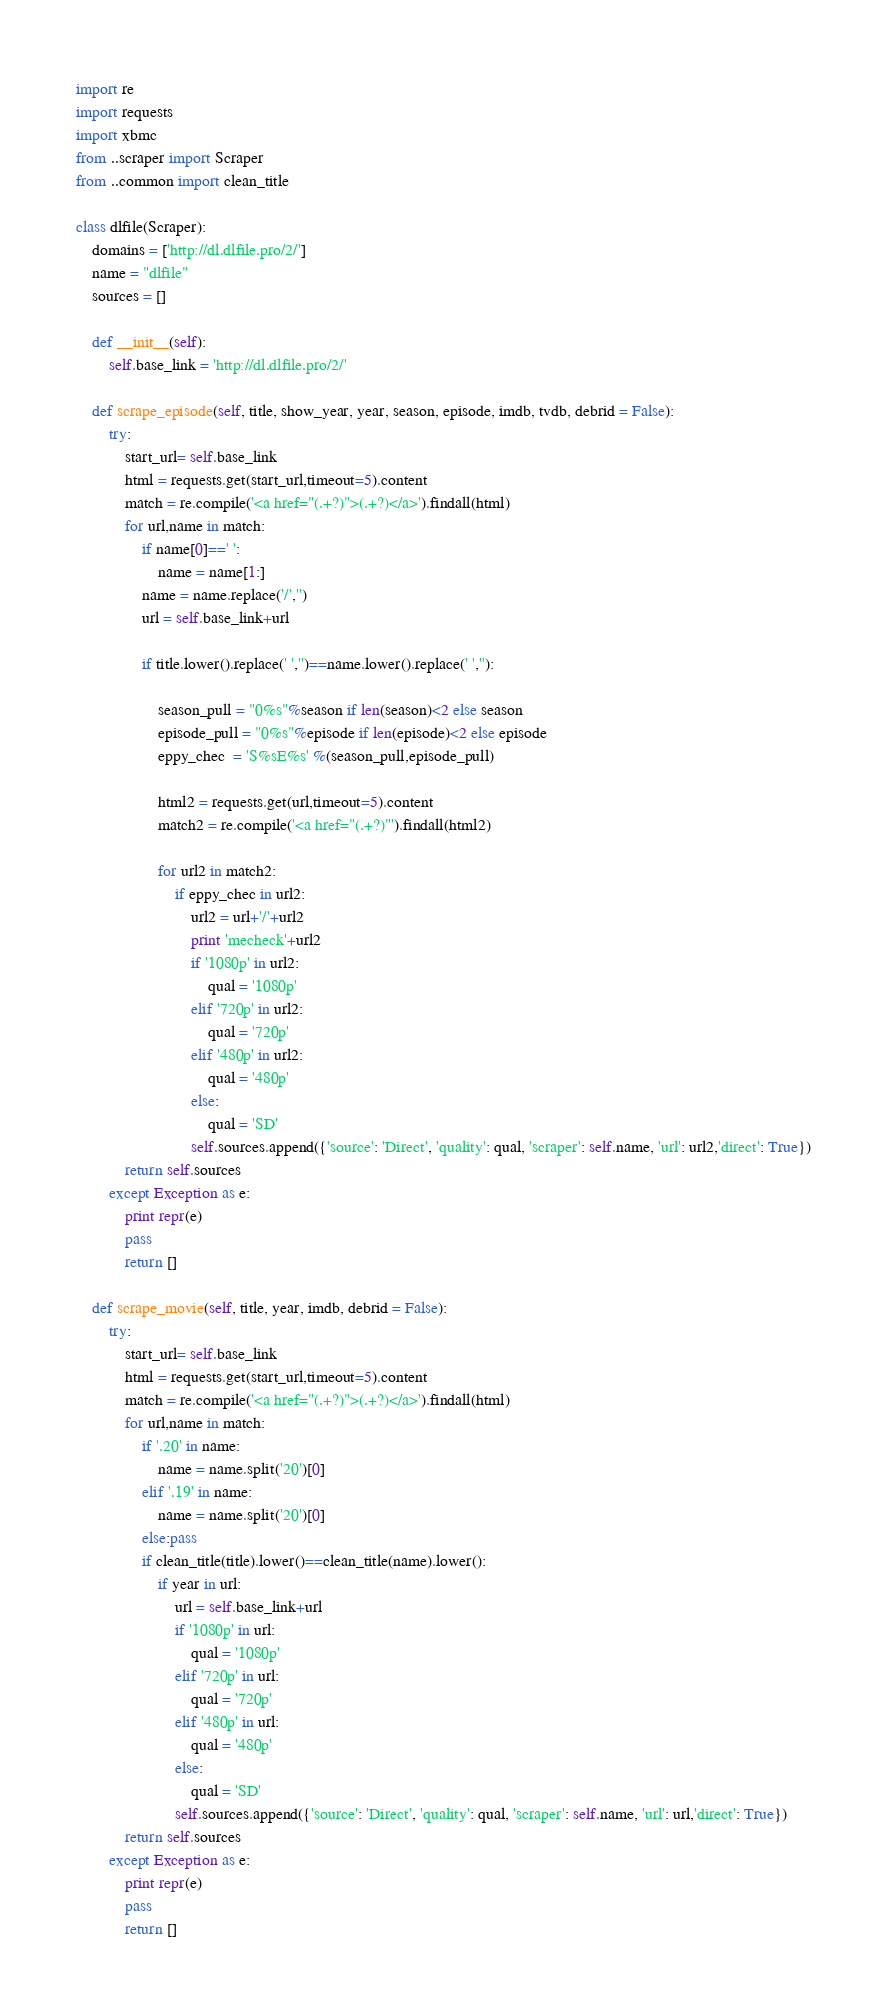<code> <loc_0><loc_0><loc_500><loc_500><_Python_>import re
import requests
import xbmc
from ..scraper import Scraper
from ..common import clean_title

class dlfile(Scraper):
    domains = ['http://dl.dlfile.pro/2/']
    name = "dlfile"
    sources = []

    def __init__(self):
        self.base_link = 'http://dl.dlfile.pro/2/'
                          
    def scrape_episode(self, title, show_year, year, season, episode, imdb, tvdb, debrid = False):
        try:
            start_url= self.base_link
            html = requests.get(start_url,timeout=5).content                               
            match = re.compile('<a href="(.+?)">(.+?)</a>').findall(html)                  
            for url,name in match:
                if name[0]==' ':
                    name = name[1:]
                name = name.replace('/','')
                url = self.base_link+url                                                 

                if title.lower().replace(' ','')==name.lower().replace(' ',''):          
                    
                    season_pull = "0%s"%season if len(season)<2 else season              
                    episode_pull = "0%s"%episode if len(episode)<2 else episode          
                    eppy_chec  = 'S%sE%s' %(season_pull,episode_pull)                    
                    
                    html2 = requests.get(url,timeout=5).content                          
                    match2 = re.compile('<a href="(.+?)"').findall(html2)                

                    for url2 in match2:
                        if eppy_chec in url2:                                            
                            url2 = url+'/'+url2                                          
                            print 'mecheck'+url2
                            if '1080p' in url2:                                         
                                qual = '1080p'
                            elif '720p' in url2: 
                                qual = '720p'
                            elif '480p' in url2:
                                qual = '480p'
                            else:
                                qual = 'SD'
                            self.sources.append({'source': 'Direct', 'quality': qual, 'scraper': self.name, 'url': url2,'direct': True})
            return self.sources
        except Exception as e:
            print repr(e)
            pass
            return []

    def scrape_movie(self, title, year, imdb, debrid = False):
        try:
            start_url= self.base_link
            html = requests.get(start_url,timeout=5).content 
            match = re.compile('<a href="(.+?)">(.+?)</a>').findall(html)
            for url,name in match:
                if '.20' in name:
                    name = name.split('20')[0]
                elif '.19' in name:
                    name = name.split('20')[0]
                else:pass
                if clean_title(title).lower()==clean_title(name).lower():
                    if year in url:
                        url = self.base_link+url
                        if '1080p' in url:                                          
                            qual = '1080p'
                        elif '720p' in url: 
                            qual = '720p'
                        elif '480p' in url:
                            qual = '480p'
                        else:
                            qual = 'SD'
                        self.sources.append({'source': 'Direct', 'quality': qual, 'scraper': self.name, 'url': url,'direct': True})
            return self.sources
        except Exception as e:
            print repr(e)
            pass
            return []                    
</code> 